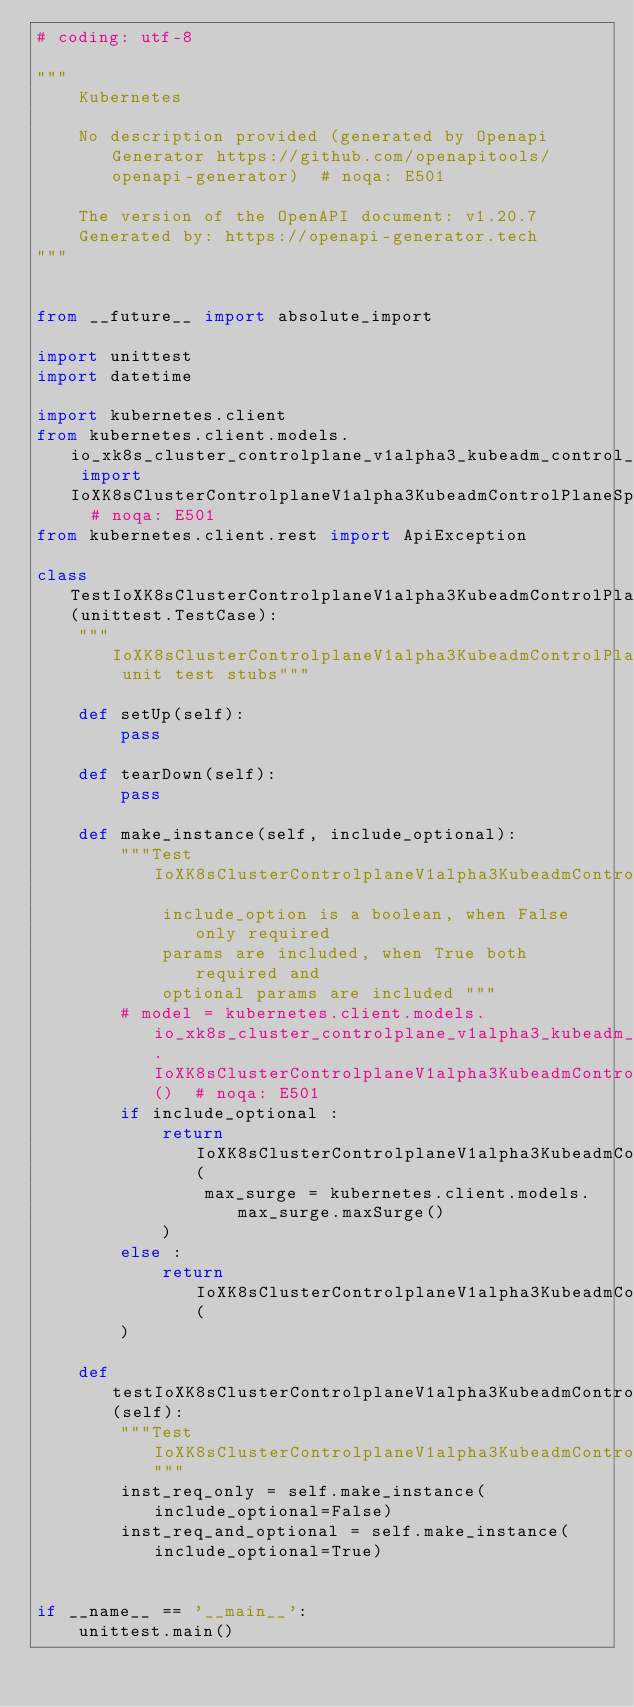<code> <loc_0><loc_0><loc_500><loc_500><_Python_># coding: utf-8

"""
    Kubernetes

    No description provided (generated by Openapi Generator https://github.com/openapitools/openapi-generator)  # noqa: E501

    The version of the OpenAPI document: v1.20.7
    Generated by: https://openapi-generator.tech
"""


from __future__ import absolute_import

import unittest
import datetime

import kubernetes.client
from kubernetes.client.models.io_xk8s_cluster_controlplane_v1alpha3_kubeadm_control_plane_spec_rollout_strategy_rolling_update import IoXK8sClusterControlplaneV1alpha3KubeadmControlPlaneSpecRolloutStrategyRollingUpdate  # noqa: E501
from kubernetes.client.rest import ApiException

class TestIoXK8sClusterControlplaneV1alpha3KubeadmControlPlaneSpecRolloutStrategyRollingUpdate(unittest.TestCase):
    """IoXK8sClusterControlplaneV1alpha3KubeadmControlPlaneSpecRolloutStrategyRollingUpdate unit test stubs"""

    def setUp(self):
        pass

    def tearDown(self):
        pass

    def make_instance(self, include_optional):
        """Test IoXK8sClusterControlplaneV1alpha3KubeadmControlPlaneSpecRolloutStrategyRollingUpdate
            include_option is a boolean, when False only required
            params are included, when True both required and
            optional params are included """
        # model = kubernetes.client.models.io_xk8s_cluster_controlplane_v1alpha3_kubeadm_control_plane_spec_rollout_strategy_rolling_update.IoXK8sClusterControlplaneV1alpha3KubeadmControlPlaneSpecRolloutStrategyRollingUpdate()  # noqa: E501
        if include_optional :
            return IoXK8sClusterControlplaneV1alpha3KubeadmControlPlaneSpecRolloutStrategyRollingUpdate(
                max_surge = kubernetes.client.models.max_surge.maxSurge()
            )
        else :
            return IoXK8sClusterControlplaneV1alpha3KubeadmControlPlaneSpecRolloutStrategyRollingUpdate(
        )

    def testIoXK8sClusterControlplaneV1alpha3KubeadmControlPlaneSpecRolloutStrategyRollingUpdate(self):
        """Test IoXK8sClusterControlplaneV1alpha3KubeadmControlPlaneSpecRolloutStrategyRollingUpdate"""
        inst_req_only = self.make_instance(include_optional=False)
        inst_req_and_optional = self.make_instance(include_optional=True)


if __name__ == '__main__':
    unittest.main()
</code> 